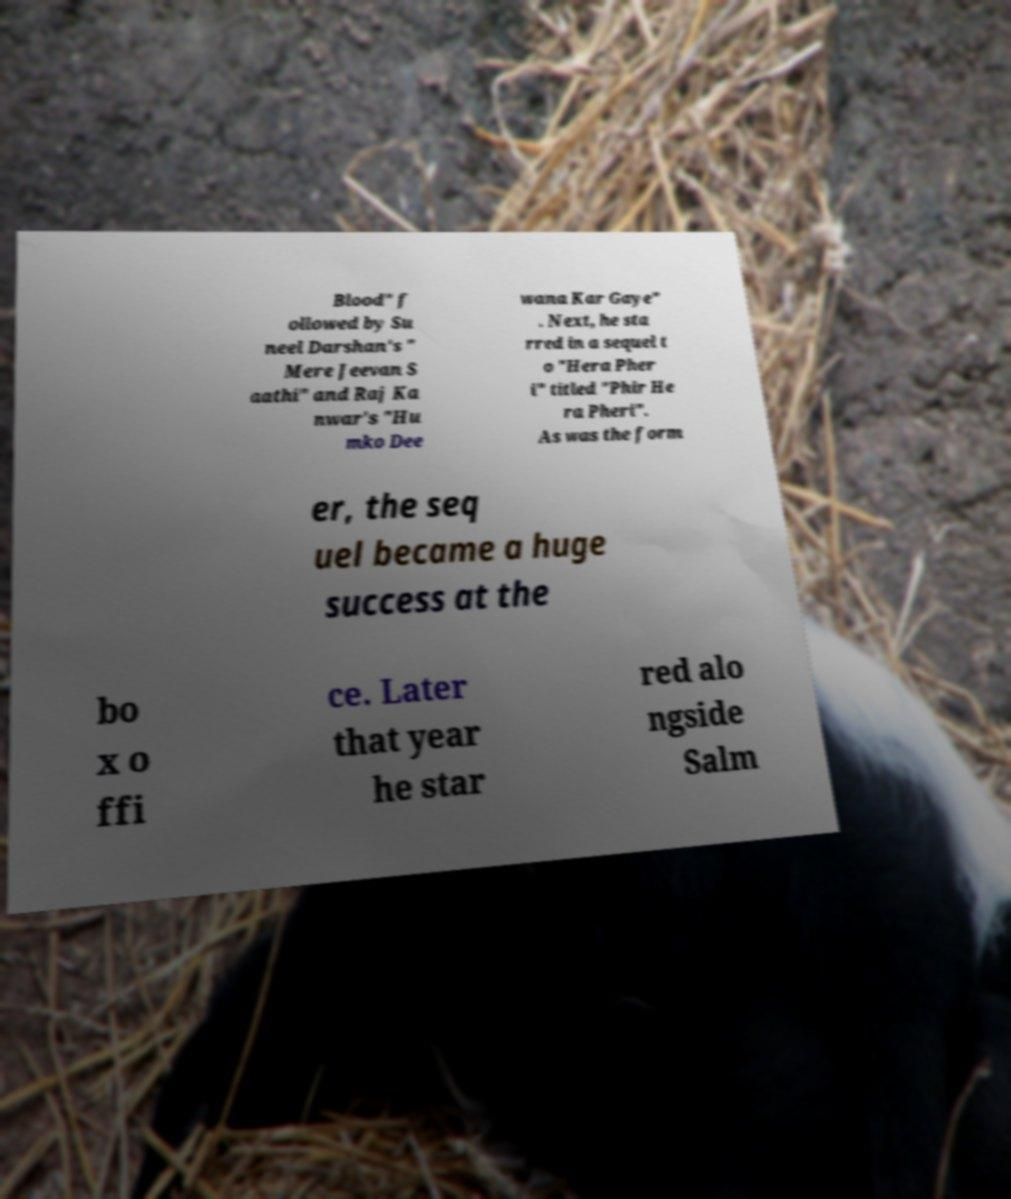There's text embedded in this image that I need extracted. Can you transcribe it verbatim? Blood" f ollowed by Su neel Darshan's " Mere Jeevan S aathi" and Raj Ka nwar's "Hu mko Dee wana Kar Gaye" . Next, he sta rred in a sequel t o "Hera Pher i" titled "Phir He ra Pheri". As was the form er, the seq uel became a huge success at the bo x o ffi ce. Later that year he star red alo ngside Salm 